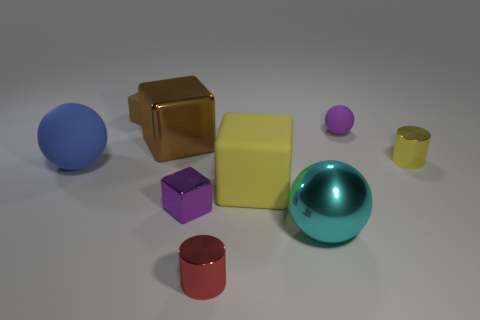How many cyan objects are either balls or matte balls?
Keep it short and to the point. 1. The big metal cube has what color?
Offer a very short reply. Brown. Do the blue matte object and the cyan thing have the same size?
Provide a succinct answer. Yes. Is there any other thing that has the same shape as the tiny yellow metallic thing?
Your response must be concise. Yes. Is the material of the small brown thing the same as the large sphere right of the small red metallic cylinder?
Ensure brevity in your answer.  No. There is a large ball that is behind the big metallic ball; does it have the same color as the large metal ball?
Offer a terse response. No. What number of things are behind the large blue rubber sphere and to the left of the tiny brown cube?
Offer a terse response. 0. What number of other objects are the same material as the tiny brown object?
Offer a terse response. 3. Are the tiny purple object that is in front of the large brown object and the cyan sphere made of the same material?
Give a very brief answer. Yes. There is a matte cube in front of the yellow metal cylinder that is behind the large sphere on the right side of the brown rubber block; what size is it?
Offer a terse response. Large. 